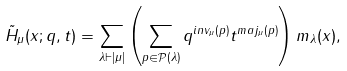<formula> <loc_0><loc_0><loc_500><loc_500>\tilde { H } _ { \mu } ( x ; q , t ) = \sum _ { \lambda \vdash | \mu | } \left ( \sum _ { p \in \mathcal { P } ( \lambda ) } q ^ { i n v _ { \mu } ( p ) } t ^ { m a j _ { \mu } ( p ) } \right ) m _ { \lambda } ( x ) ,</formula> 